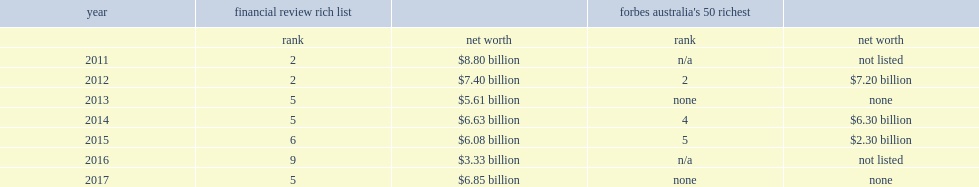In 2017, what is th net worth of glassenberg according to the financial review rich list? $6.85 billion. 